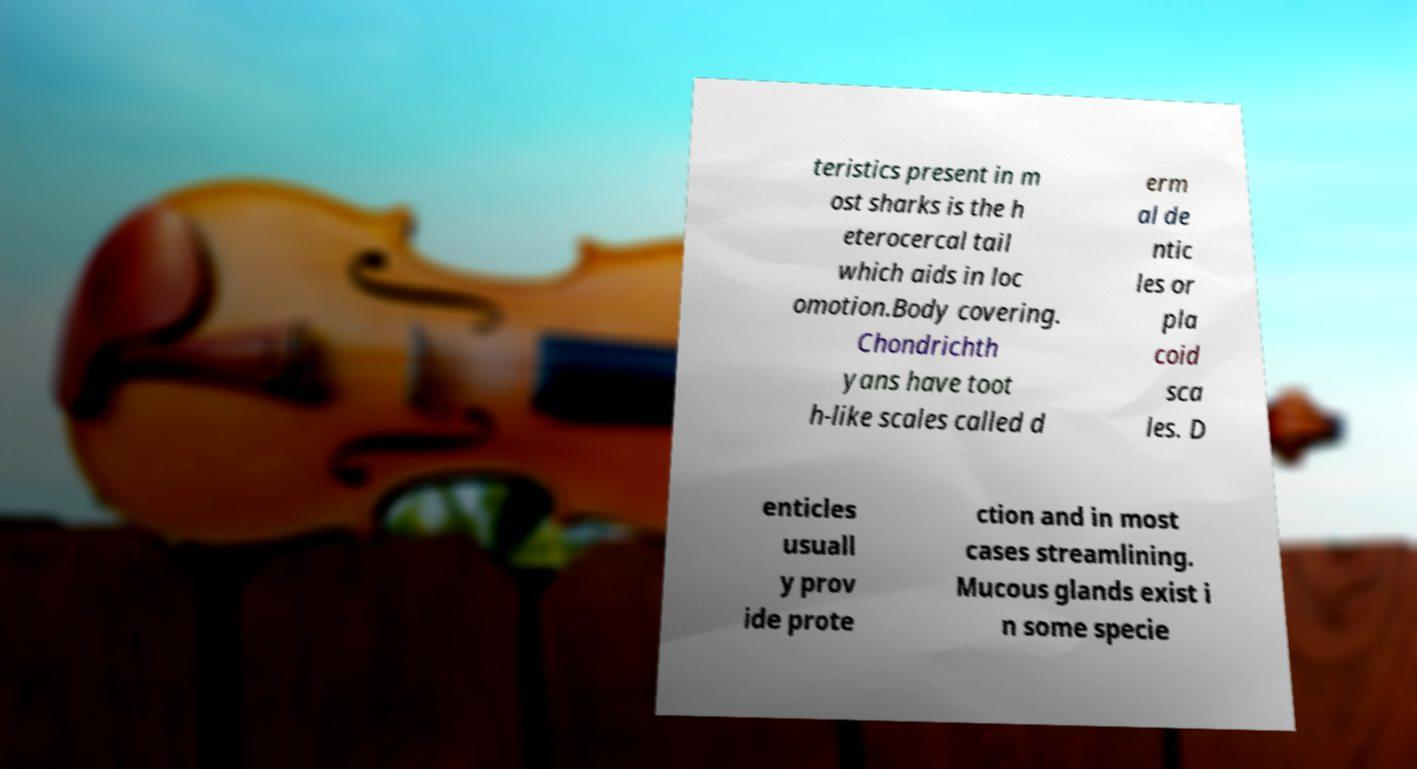Could you assist in decoding the text presented in this image and type it out clearly? teristics present in m ost sharks is the h eterocercal tail which aids in loc omotion.Body covering. Chondrichth yans have toot h-like scales called d erm al de ntic les or pla coid sca les. D enticles usuall y prov ide prote ction and in most cases streamlining. Mucous glands exist i n some specie 